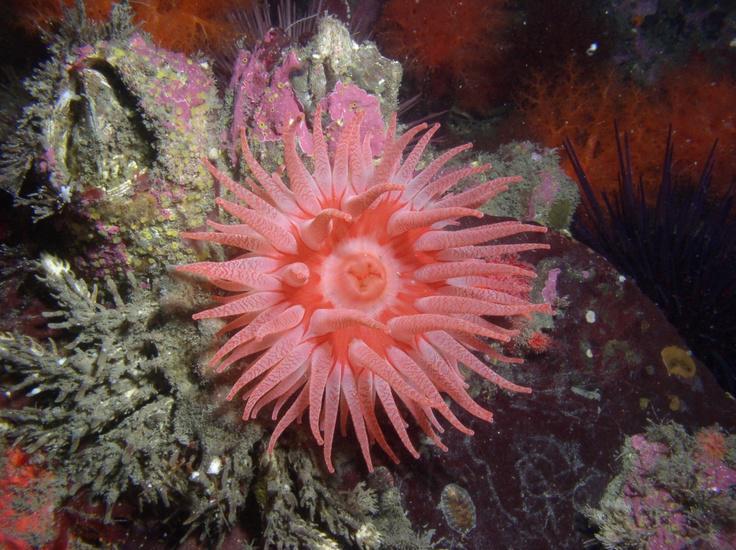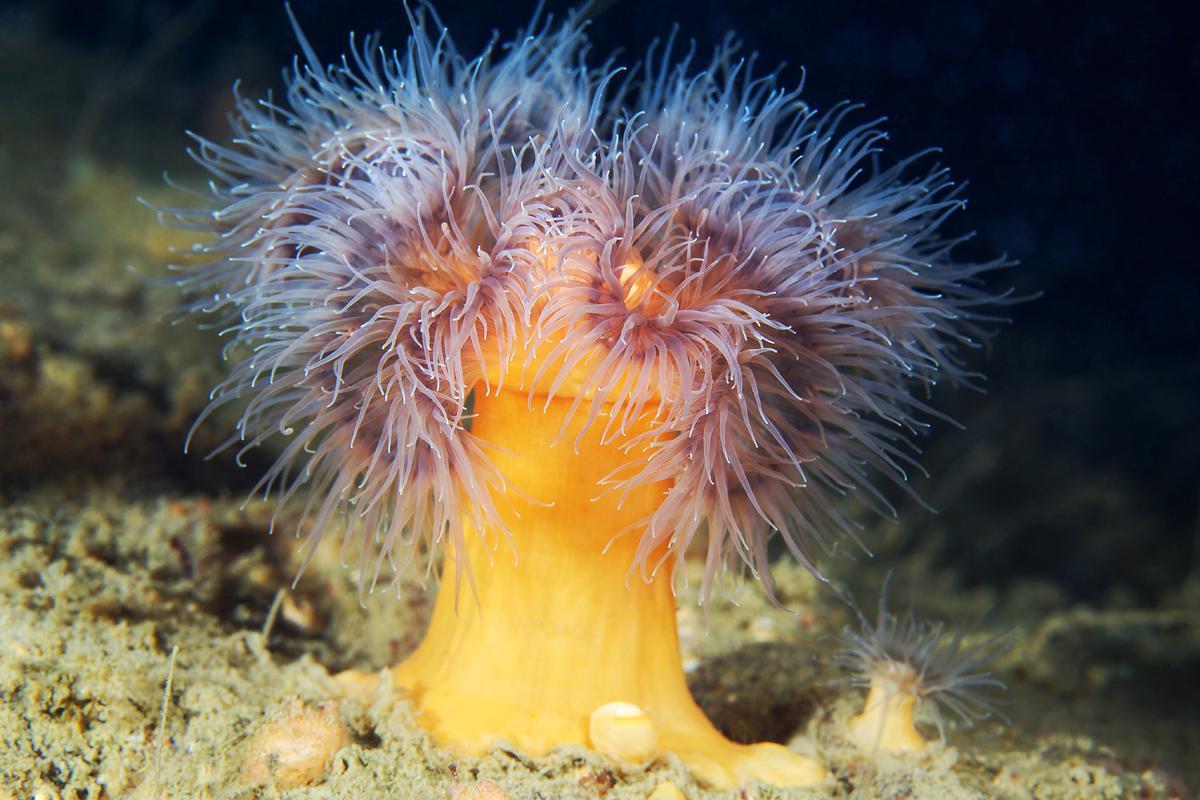The first image is the image on the left, the second image is the image on the right. Considering the images on both sides, is "The left image includes at least eight yellowish anemone that resemble flowers." valid? Answer yes or no. No. The first image is the image on the left, the second image is the image on the right. Considering the images on both sides, is "In at least one image there is a peach corral with no less than twenty tentacles being moved by the water." valid? Answer yes or no. Yes. 